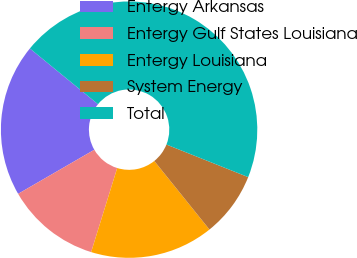Convert chart. <chart><loc_0><loc_0><loc_500><loc_500><pie_chart><fcel>Entergy Arkansas<fcel>Entergy Gulf States Louisiana<fcel>Entergy Louisiana<fcel>System Energy<fcel>Total<nl><fcel>19.26%<fcel>11.87%<fcel>15.57%<fcel>8.18%<fcel>45.13%<nl></chart> 